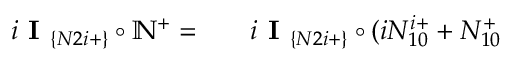Convert formula to latex. <formula><loc_0><loc_0><loc_500><loc_500>\begin{array} { r l r } { i I _ { \{ N 2 i + \} } \circ \mathbb { N } ^ { + } = } & { i I _ { \{ N 2 i + \} } \circ ( i N _ { 1 0 } ^ { i + } + N _ { 1 0 } ^ { + } } \end{array}</formula> 